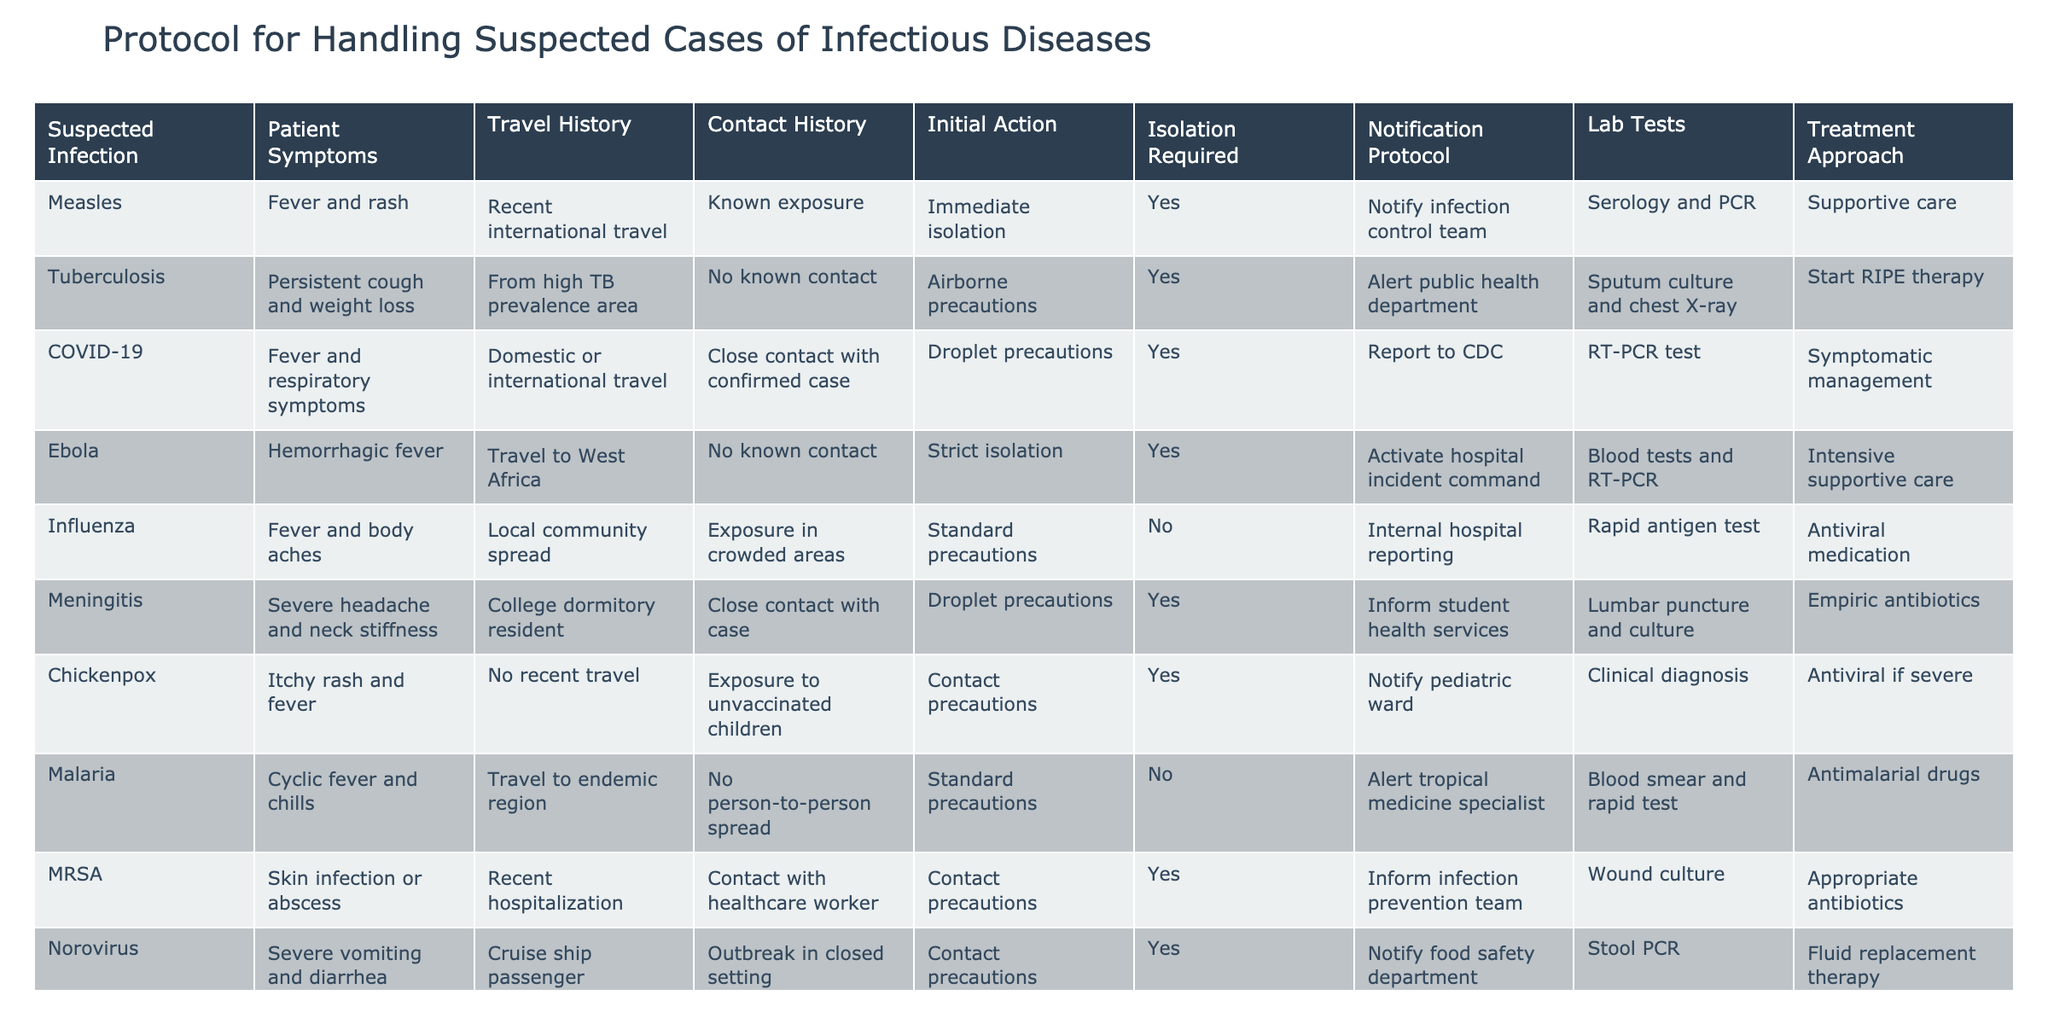What is the initial action for suspected cases of Measles? The table indicates that for suspected cases of Measles, the initial action is "Immediate isolation." This can be found under the "Initial Action" column next to the row that lists Measles.
Answer: Immediate isolation How many infectious diseases listed require notification to an infection control team? The table shows that three conditions require notification to an infection control team: Measles, Meningitis, and MRSA. By counting these entries, we determine that there are three diseases.
Answer: Three Is isolation required for cases of Influenza? In the row for Influenza, the table states "No" under the "Isolation Required" column. This means that isolation is not necessary for suspected cases of Influenza.
Answer: No Which infectious disease has the most complex treatment approach listed? The most complex treatment approach listed is for Ebola, which indicates "Intensive supportive care." To find this, I compared the treatment approaches for all infectious diseases and determined that Ebola requires the most intensive care.
Answer: Ebola What is the common initial action for diseases requiring droplet precautions? The diseases that require droplet precautions are Tuberculosis, COVID-19, and Meningitis, and their initial actions are "Airborne precautions," "Droplet precautions," and "Droplet precautions," respectively. The commonality affects patient management but varies in phrasing, so there isn't a single action listed.
Answer: Not a single common action How many cases include symptoms of fever? By scanning through the symptoms listed, we see that Measles, COVID-19, Influenza, Meningitis, Chickenpox, and Ebola all include "fever" as a symptom. This totals six cases.
Answer: Six Do any infections require tests specifically for stool? The table indicates that only Norovirus requires stool samples for testing, which is mentioned in the "Lab Tests" column. Therefore, the answer is a single infection that requires stool testing.
Answer: Yes, Norovirus If a patient has traveled to a high TB prevalence area, what precautions should be taken? According to the table under Tuberculosis, patients from high TB prevalence areas should undergo "Airborne precautions," which is their initial action in response to their risks.
Answer: Airborne precautions What is the notification protocol for suspected cases of Chickenpox? The table shows that suspected cases of Chickenpox require notifying the pediatric ward. This information can be directly found in the corresponding row for Chickenpox under the "Notification Protocol" column.
Answer: Notify pediatric ward 